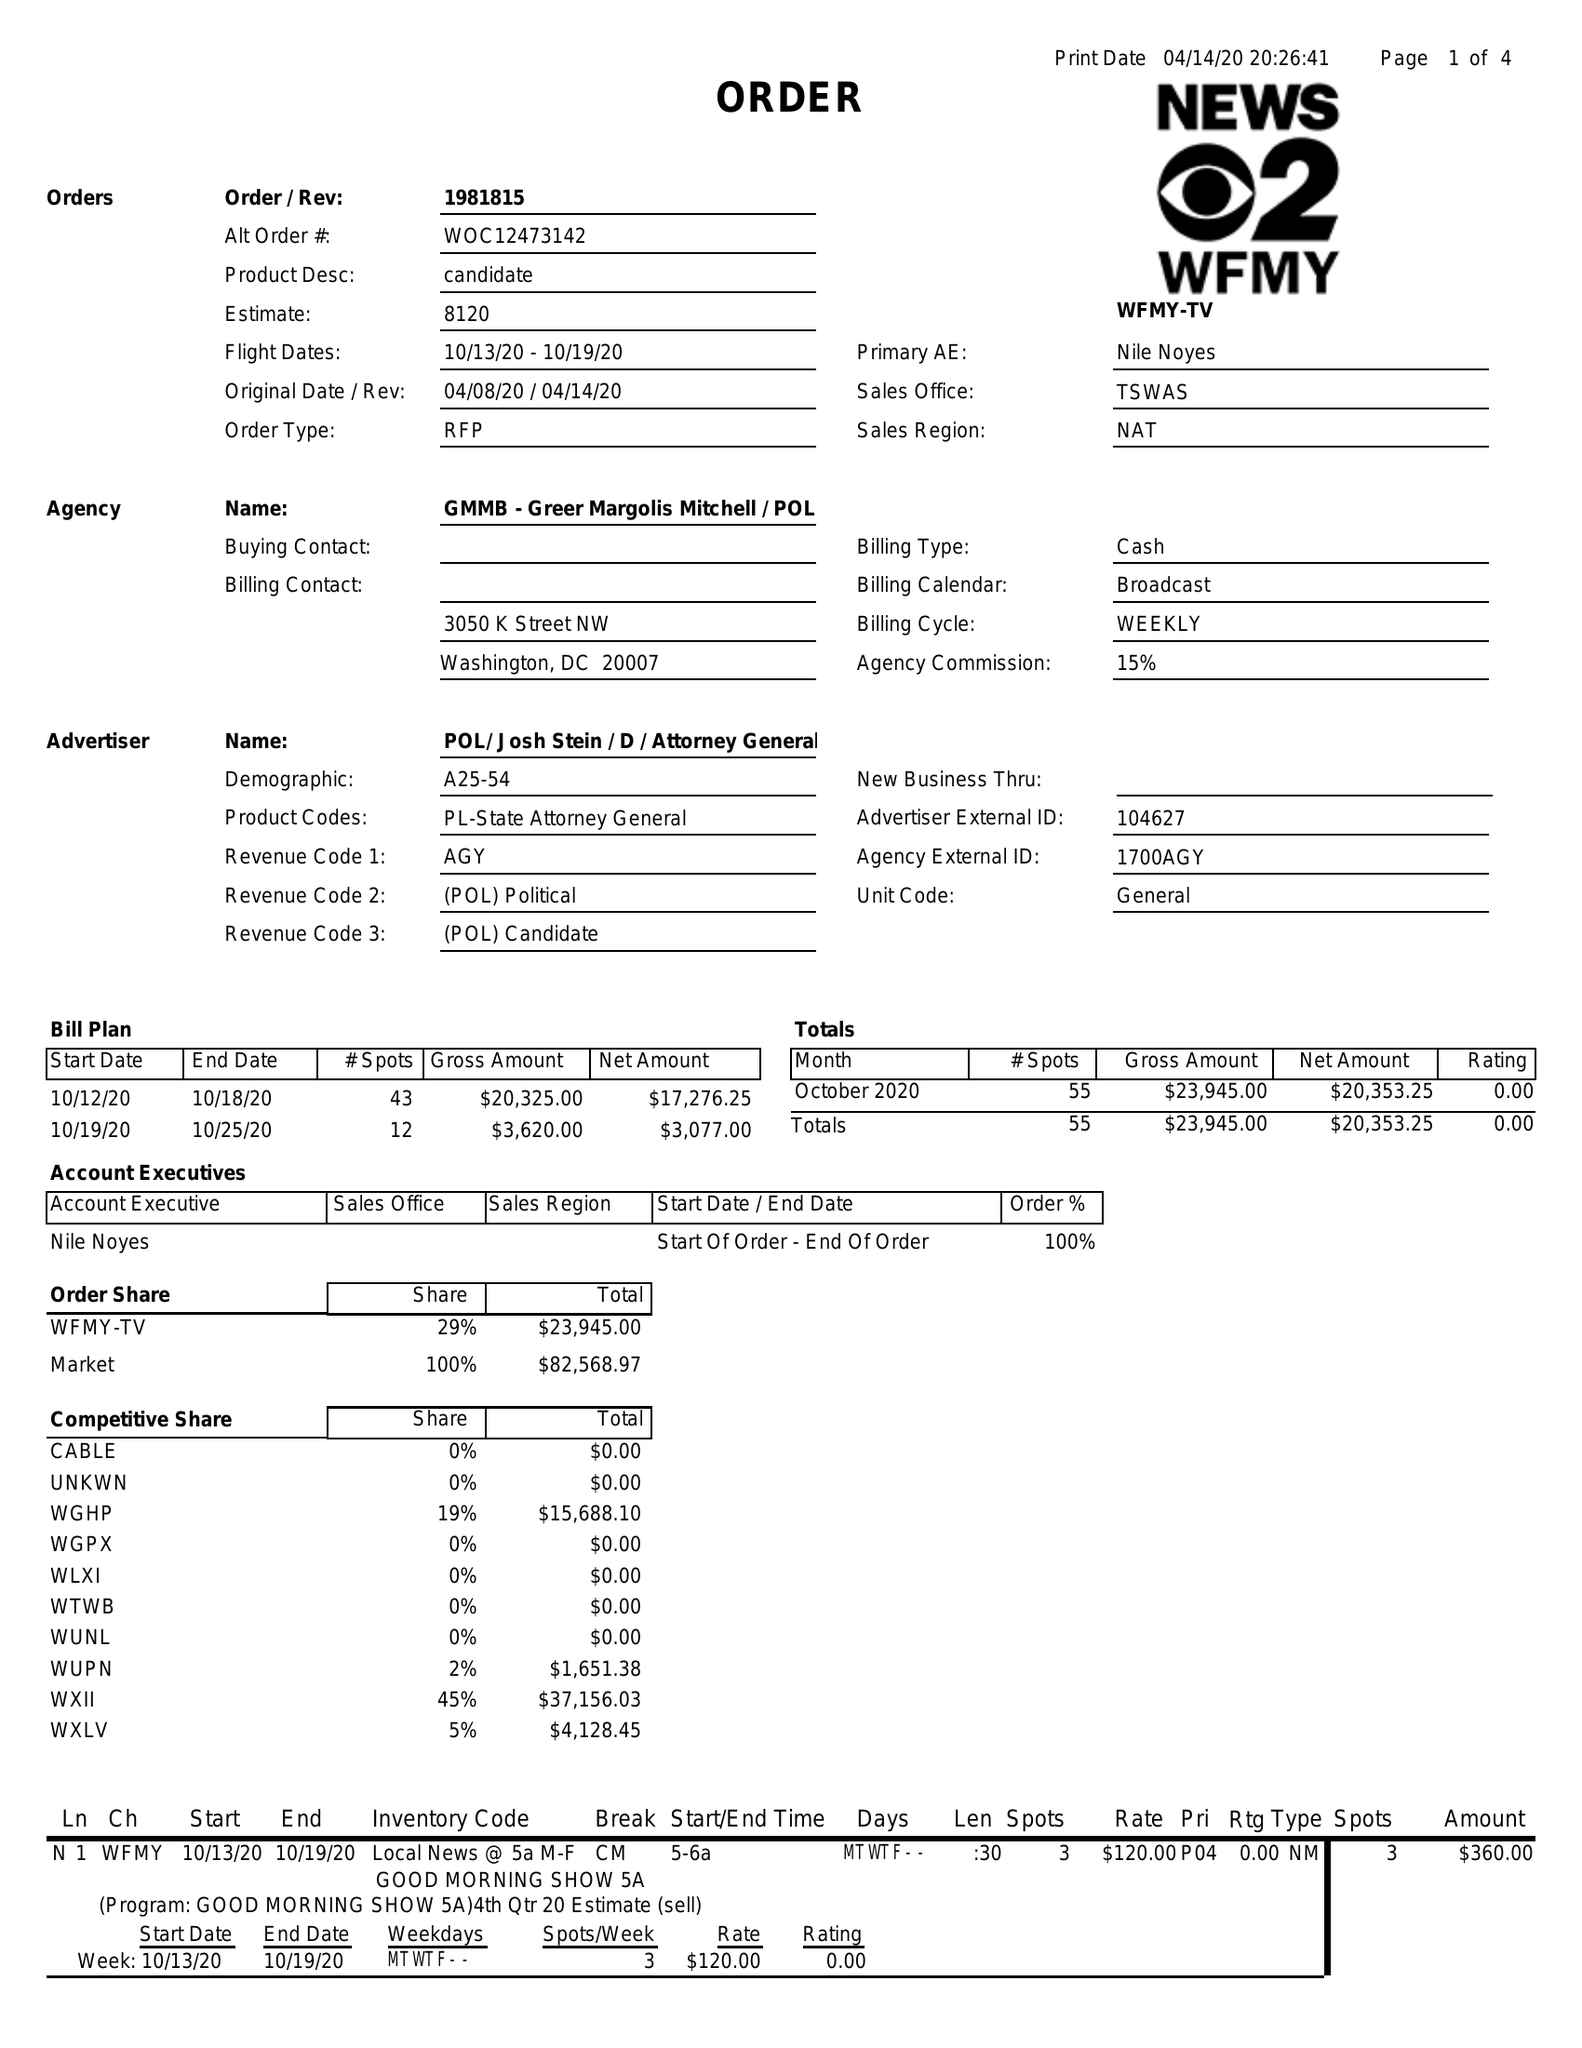What is the value for the gross_amount?
Answer the question using a single word or phrase. 23945.00 